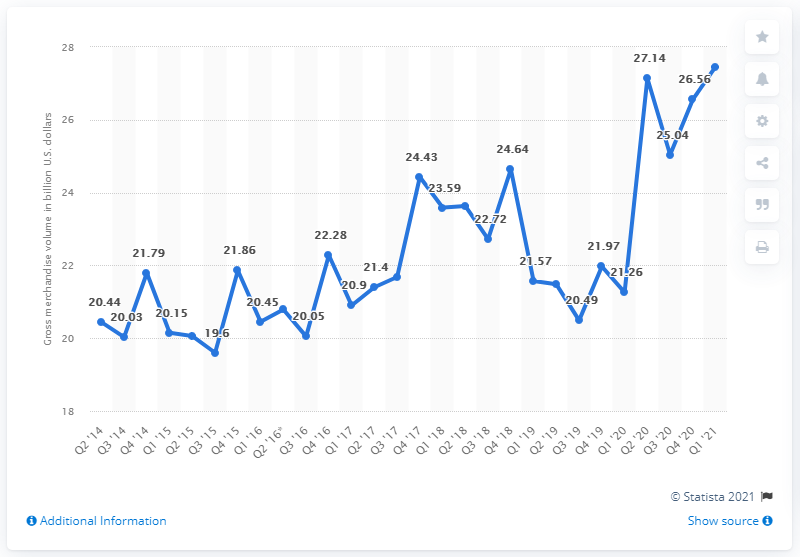Mention a couple of crucial points in this snapshot. In the fourth quarter of 2014, eBay's gross merchandise volume was 27.46. 